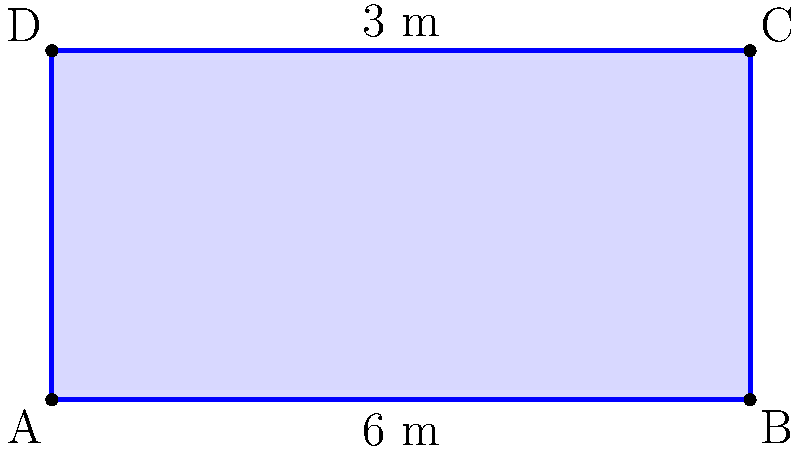The doctor has provided you with a special treatment bed to help you recover from cholera. The bed is rectangular in shape. If the length of the bed is 6 meters and the width is 3 meters, what is the area of the bed in square meters? To find the area of a rectangular bed, we need to multiply its length by its width.

Given:
- Length of the bed = 6 meters
- Width of the bed = 3 meters

Step 1: Set up the formula for the area of a rectangle.
Area = Length × Width

Step 2: Substitute the known values into the formula.
Area = 6 m × 3 m

Step 3: Multiply the numbers.
Area = 18 m²

Therefore, the area of the treatment bed is 18 square meters.
Answer: 18 m² 